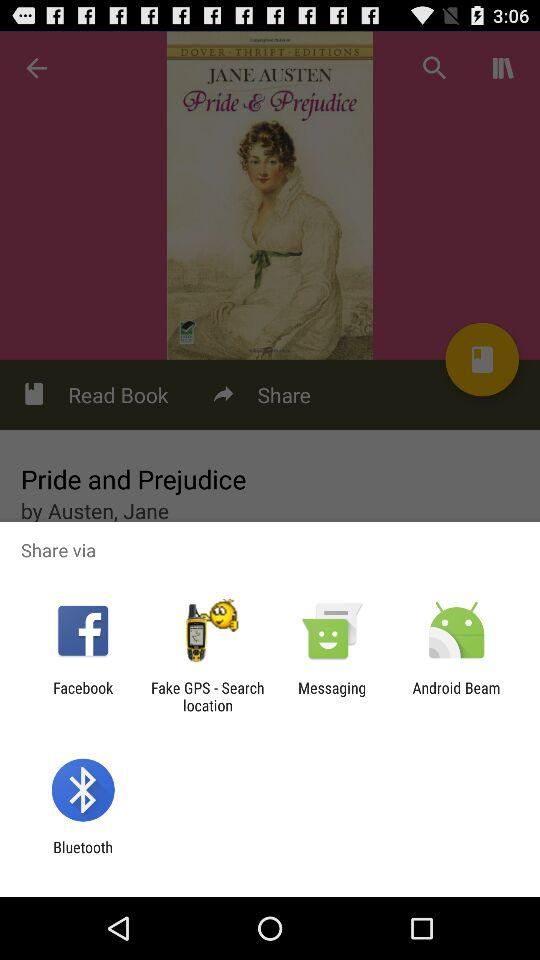What's the title of the book? The title of the book is "Pride and Prejudice". 